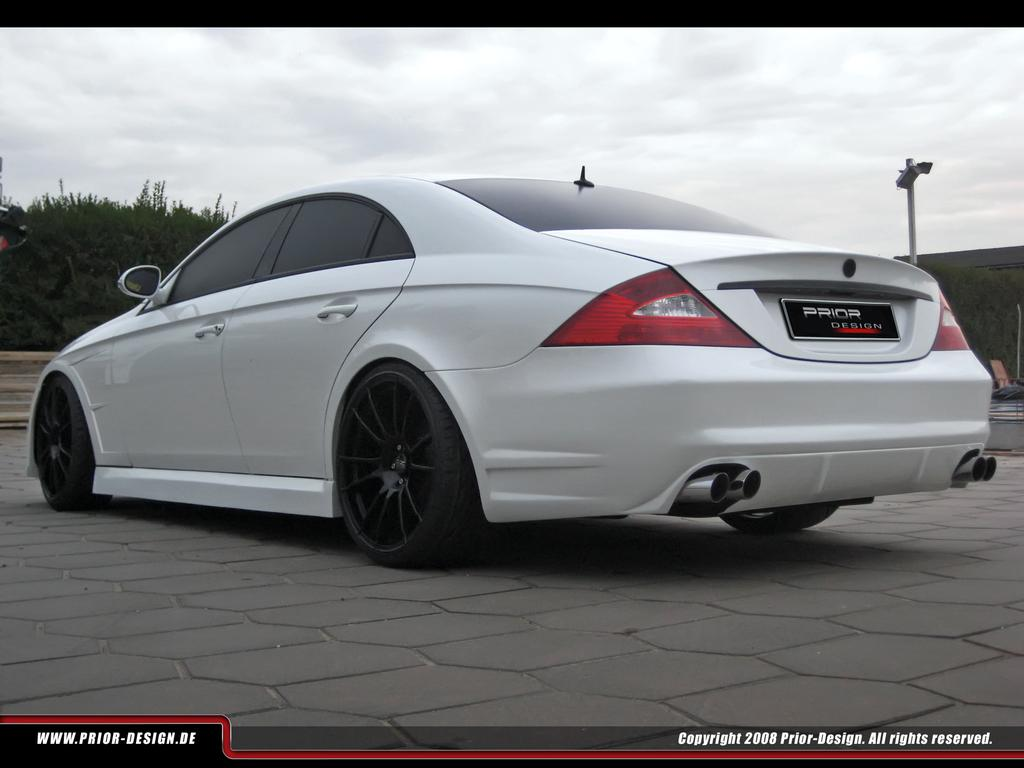What is the main subject of the image? There is a car in the center of the image. Where is the car located? The car is on the road. What can be seen in the background of the image? There are trees, a wall, and the sky visible in the background of the image. What is the condition of the sky in the image? Clouds are present in the sky. Is there any text in the image? Yes, there is text at the bottom of the image. What type of butter is being used to improve the acoustics of the car in the image? There is no butter or mention of acoustics in the image; it simply features a car on the road with a background of trees, a wall, and the sky. 